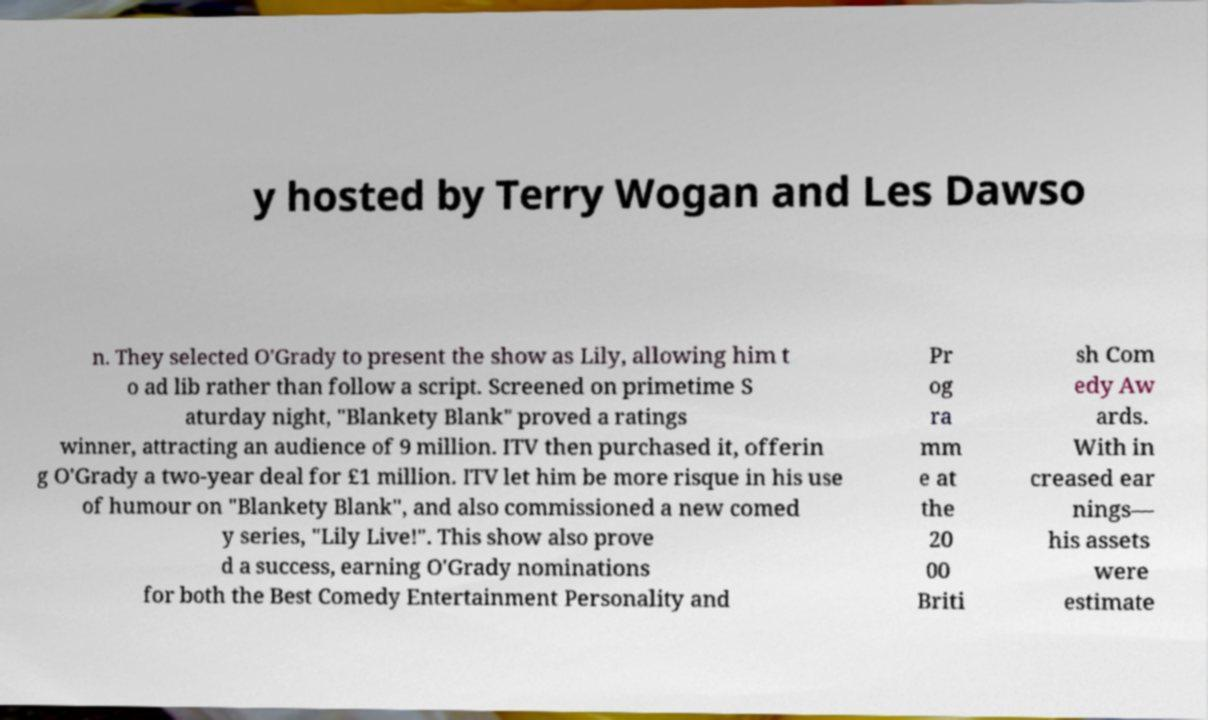For documentation purposes, I need the text within this image transcribed. Could you provide that? y hosted by Terry Wogan and Les Dawso n. They selected O'Grady to present the show as Lily, allowing him t o ad lib rather than follow a script. Screened on primetime S aturday night, "Blankety Blank" proved a ratings winner, attracting an audience of 9 million. ITV then purchased it, offerin g O'Grady a two-year deal for £1 million. ITV let him be more risque in his use of humour on "Blankety Blank", and also commissioned a new comed y series, "Lily Live!". This show also prove d a success, earning O'Grady nominations for both the Best Comedy Entertainment Personality and Pr og ra mm e at the 20 00 Briti sh Com edy Aw ards. With in creased ear nings— his assets were estimate 